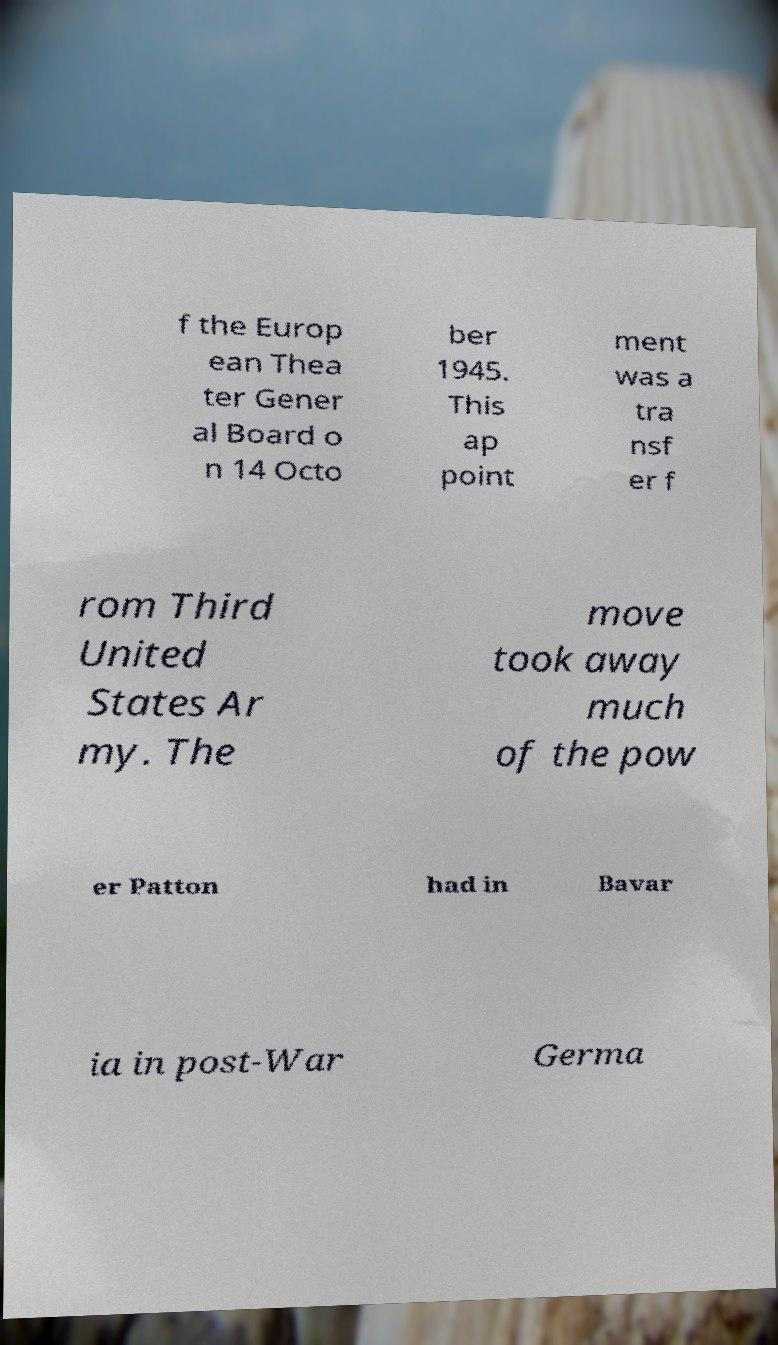Can you read and provide the text displayed in the image?This photo seems to have some interesting text. Can you extract and type it out for me? f the Europ ean Thea ter Gener al Board o n 14 Octo ber 1945. This ap point ment was a tra nsf er f rom Third United States Ar my. The move took away much of the pow er Patton had in Bavar ia in post-War Germa 